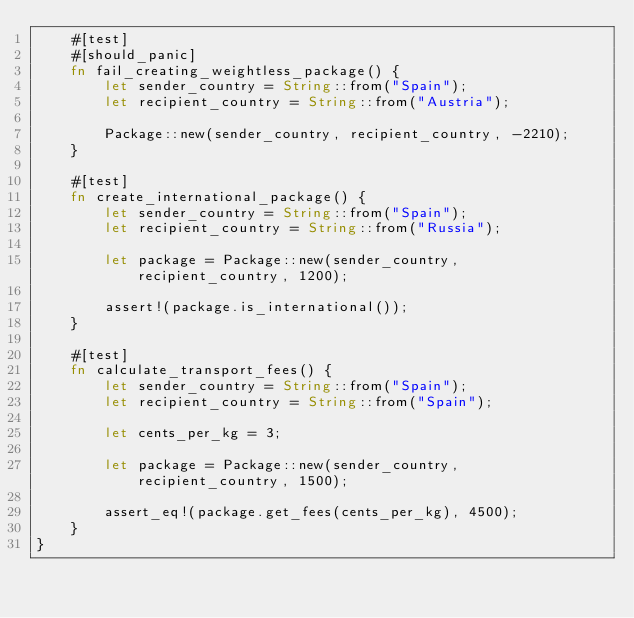Convert code to text. <code><loc_0><loc_0><loc_500><loc_500><_Rust_>    #[test]
    #[should_panic]
    fn fail_creating_weightless_package() {
        let sender_country = String::from("Spain");
        let recipient_country = String::from("Austria");

        Package::new(sender_country, recipient_country, -2210);
    }

    #[test]
    fn create_international_package() {
        let sender_country = String::from("Spain");
        let recipient_country = String::from("Russia");
        
        let package = Package::new(sender_country, recipient_country, 1200);

        assert!(package.is_international());
    }

    #[test]
    fn calculate_transport_fees() {
        let sender_country = String::from("Spain");
        let recipient_country = String::from("Spain");

        let cents_per_kg = 3;
        
        let package = Package::new(sender_country, recipient_country, 1500);
        
        assert_eq!(package.get_fees(cents_per_kg), 4500);
    }
}
</code> 